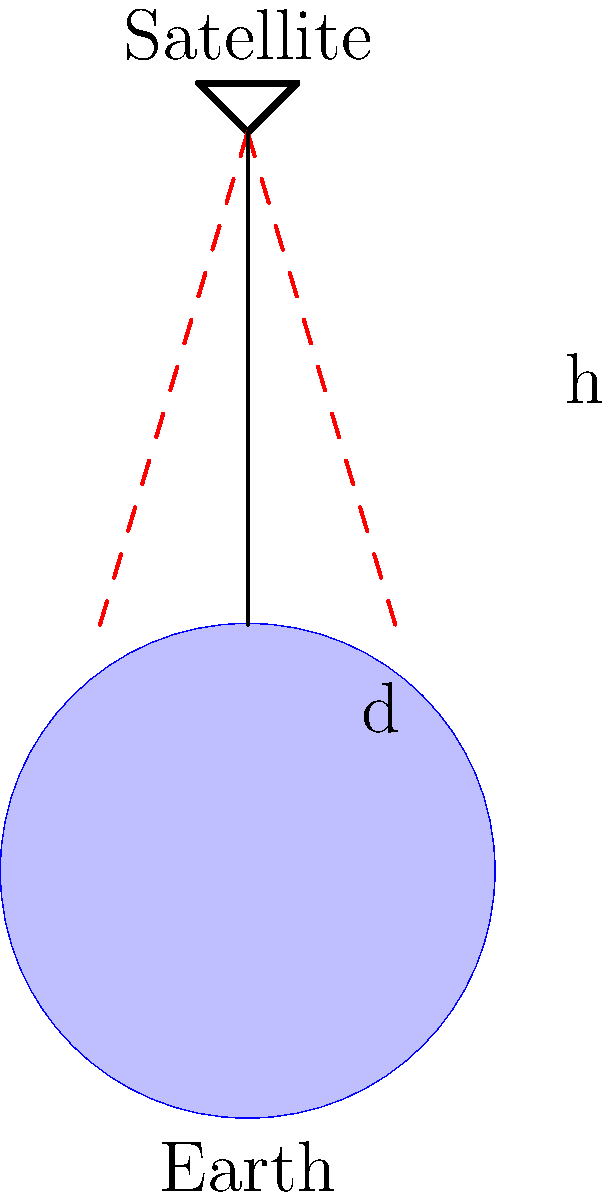A satellite is orbiting Earth at an altitude of 700 km. The satellite's camera has a focal length of 2 meters and an image sensor width of 25,000 pixels. If the ground sampling distance (GSD) is 5 meters per pixel, what is the swath width of the satellite image in kilometers? To solve this problem, we'll follow these steps:

1) First, let's define the variables:
   $h$ = altitude = 700 km
   $f$ = focal length = 2 m
   $w$ = sensor width in pixels = 25,000
   $GSD$ = 5 m/pixel

2) The swath width is the ground distance covered by the entire width of the sensor. We can calculate this by multiplying the number of pixels by the GSD:

   Swath width = $w \times GSD$
                = 25,000 pixels $\times$ 5 m/pixel
                = 125,000 m
                = 125 km

3) We can verify this result using the properties of similar triangles. The ratio of the sensor width to the focal length should be equal to the ratio of the swath width to the altitude:

   $\frac{\text{sensor width}}{\text{focal length}} = \frac{\text{swath width}}{\text{altitude}}$

4) We don't know the actual sensor width in meters, but we can calculate it:
   Sensor width = $w \times GSD \times \frac{f}{h}$
                = 25,000 $\times$ 5 $\times$ $\frac{2}{700,000}$
                = 0.357 m

5) Now we can verify:
   $\frac{0.357}{2} = \frac{125}{700}$
   
   $0.1785 = 0.1785$

This confirms our calculation is correct.
Answer: 125 km 